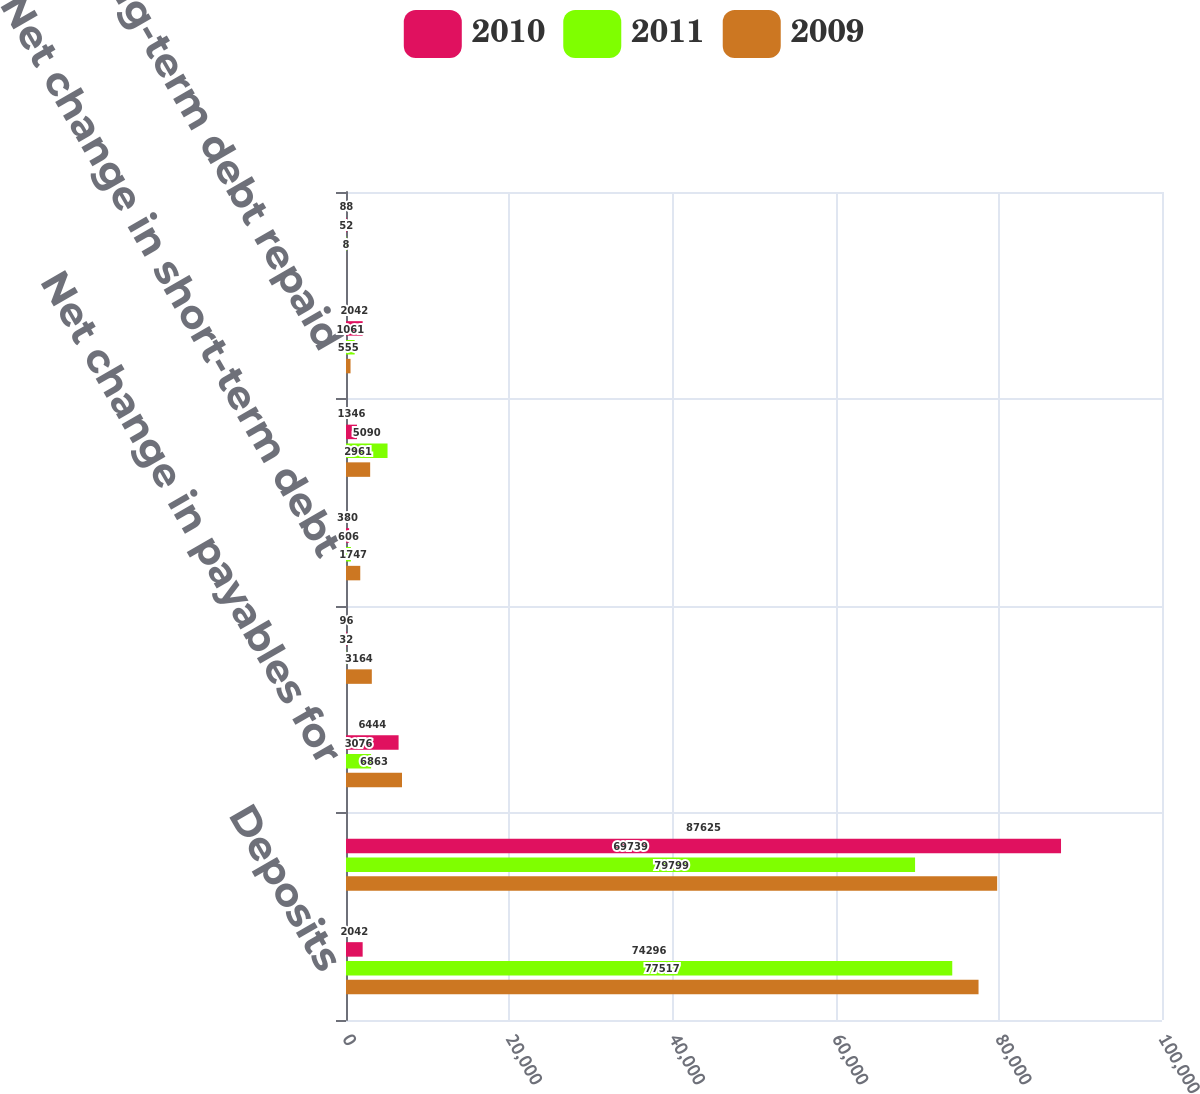Convert chart to OTSL. <chart><loc_0><loc_0><loc_500><loc_500><stacked_bar_chart><ecel><fcel>Deposits<fcel>Withdrawals<fcel>Net change in payables for<fcel>Net change in bank deposits<fcel>Net change in short-term debt<fcel>Long-term debt issued<fcel>Long-term debt repaid<fcel>Stock options exercised<nl><fcel>2010<fcel>2042<fcel>87625<fcel>6444<fcel>96<fcel>380<fcel>1346<fcel>2042<fcel>88<nl><fcel>2011<fcel>74296<fcel>69739<fcel>3076<fcel>32<fcel>606<fcel>5090<fcel>1061<fcel>52<nl><fcel>2009<fcel>77517<fcel>79799<fcel>6863<fcel>3164<fcel>1747<fcel>2961<fcel>555<fcel>8<nl></chart> 